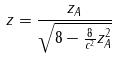<formula> <loc_0><loc_0><loc_500><loc_500>z = \frac { z _ { A } } { \sqrt { 8 - \frac { 8 } { c ^ { 2 } } z _ { A } ^ { 2 } } }</formula> 